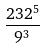<formula> <loc_0><loc_0><loc_500><loc_500>\frac { 2 3 2 ^ { 5 } } { 9 ^ { 3 } }</formula> 